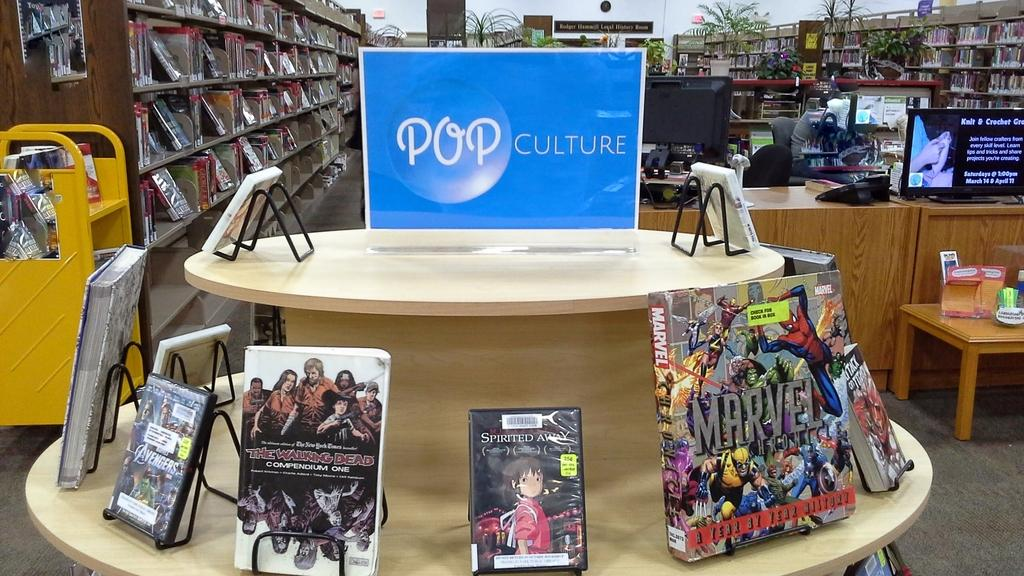What is the main object in the center of the image? There is a table in the center of the image. What items can be seen on the table? There are books and a banner on the table. What can be seen in the background of the image? There is a wall, shelves, and another table in the background of the image. What is on the shelves in the background? There are books on the shelves. What is on the table in the background? There are monitors and landline phones on the table. How many beggars are visible in the image? There are no beggars present in the image. What country is depicted in the banner on the table? The banner on the table does not depict a country; it is not mentioned in the provided facts. 